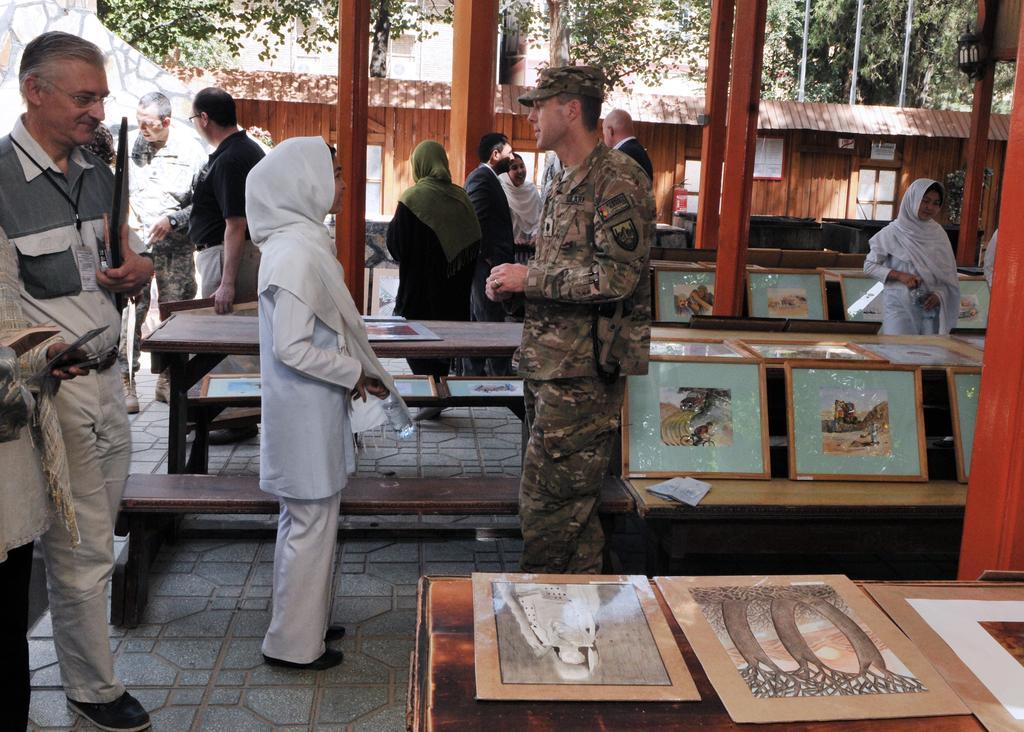Can you describe this image briefly? In this picture there is a soldier standing and there is a kid standing in front of him and there are few other persons standing beside them and there are few photo frames placed on an object in the right corner and there is a wooden house and trees in the background. 